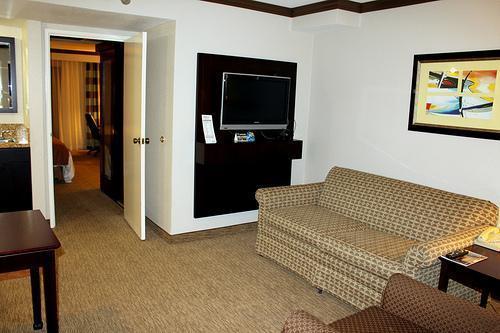How many people are on the sofa?
Give a very brief answer. 0. 